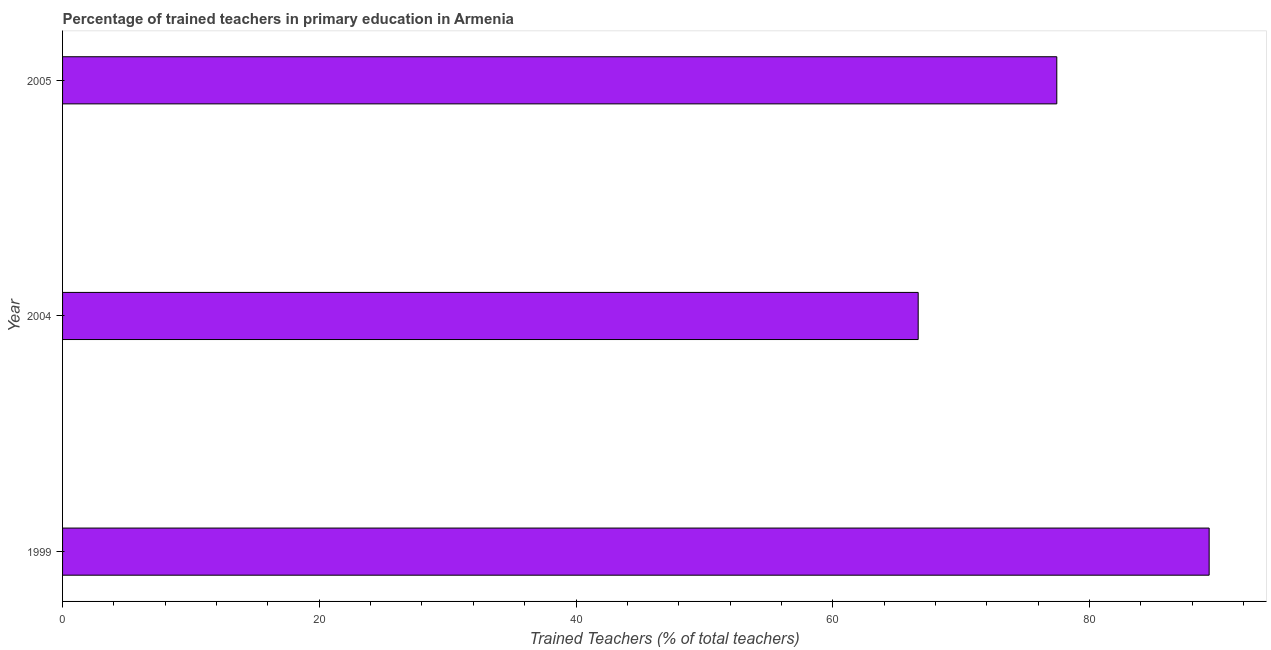Does the graph contain grids?
Ensure brevity in your answer.  No. What is the title of the graph?
Your answer should be compact. Percentage of trained teachers in primary education in Armenia. What is the label or title of the X-axis?
Ensure brevity in your answer.  Trained Teachers (% of total teachers). What is the percentage of trained teachers in 2004?
Offer a very short reply. 66.66. Across all years, what is the maximum percentage of trained teachers?
Your answer should be very brief. 89.33. Across all years, what is the minimum percentage of trained teachers?
Offer a very short reply. 66.66. In which year was the percentage of trained teachers maximum?
Your answer should be very brief. 1999. In which year was the percentage of trained teachers minimum?
Ensure brevity in your answer.  2004. What is the sum of the percentage of trained teachers?
Ensure brevity in your answer.  233.44. What is the difference between the percentage of trained teachers in 2004 and 2005?
Your response must be concise. -10.8. What is the average percentage of trained teachers per year?
Give a very brief answer. 77.81. What is the median percentage of trained teachers?
Provide a succinct answer. 77.46. What is the ratio of the percentage of trained teachers in 2004 to that in 2005?
Keep it short and to the point. 0.86. Is the percentage of trained teachers in 1999 less than that in 2004?
Your response must be concise. No. Is the difference between the percentage of trained teachers in 2004 and 2005 greater than the difference between any two years?
Your response must be concise. No. What is the difference between the highest and the second highest percentage of trained teachers?
Provide a succinct answer. 11.87. What is the difference between the highest and the lowest percentage of trained teachers?
Offer a very short reply. 22.67. In how many years, is the percentage of trained teachers greater than the average percentage of trained teachers taken over all years?
Your answer should be compact. 1. How many bars are there?
Keep it short and to the point. 3. How many years are there in the graph?
Give a very brief answer. 3. What is the difference between two consecutive major ticks on the X-axis?
Provide a short and direct response. 20. What is the Trained Teachers (% of total teachers) of 1999?
Your answer should be compact. 89.33. What is the Trained Teachers (% of total teachers) in 2004?
Offer a very short reply. 66.66. What is the Trained Teachers (% of total teachers) in 2005?
Offer a very short reply. 77.46. What is the difference between the Trained Teachers (% of total teachers) in 1999 and 2004?
Provide a short and direct response. 22.67. What is the difference between the Trained Teachers (% of total teachers) in 1999 and 2005?
Your answer should be very brief. 11.87. What is the difference between the Trained Teachers (% of total teachers) in 2004 and 2005?
Ensure brevity in your answer.  -10.8. What is the ratio of the Trained Teachers (% of total teachers) in 1999 to that in 2004?
Make the answer very short. 1.34. What is the ratio of the Trained Teachers (% of total teachers) in 1999 to that in 2005?
Provide a succinct answer. 1.15. What is the ratio of the Trained Teachers (% of total teachers) in 2004 to that in 2005?
Provide a short and direct response. 0.86. 